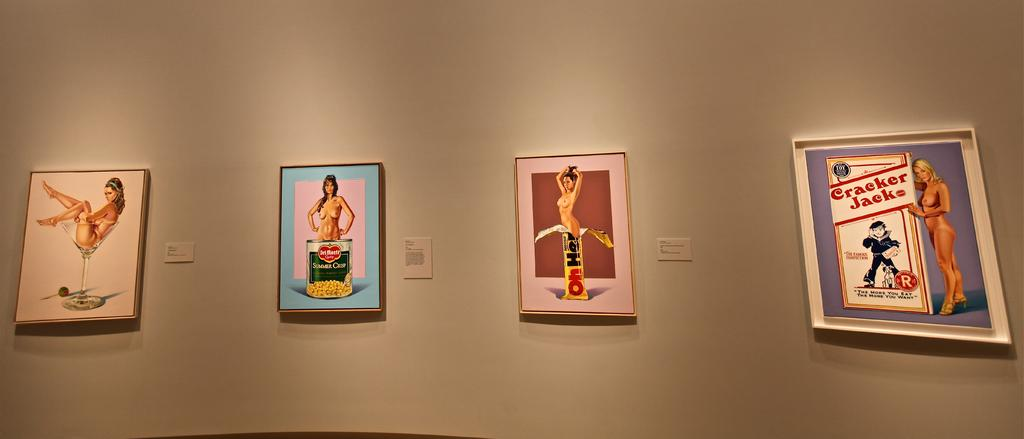Provide a one-sentence caption for the provided image. Products displayed in museum artwork include Cracker Jacks, Oh Henry candy, and Del Monte canned vegetables. 